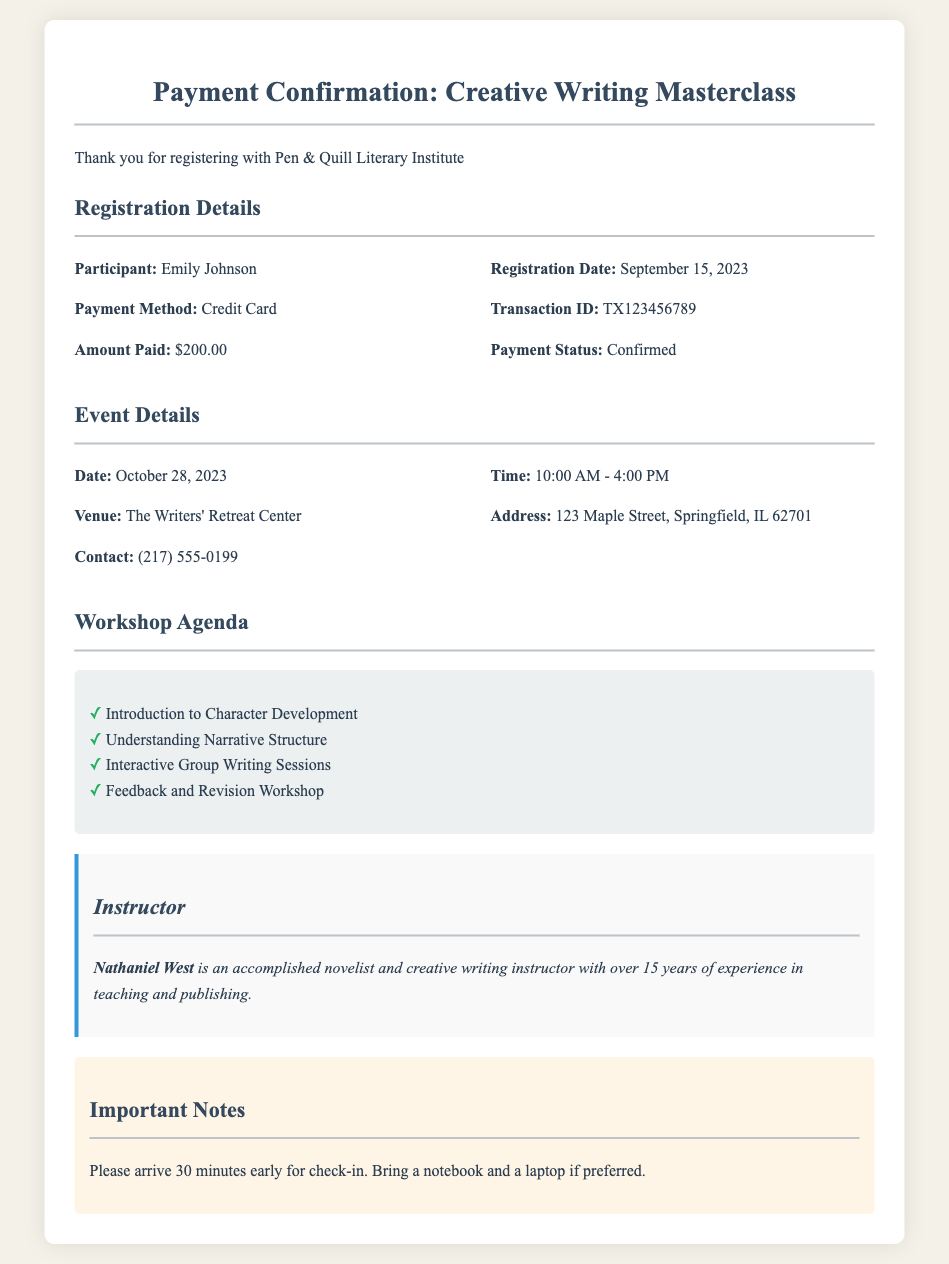What is the name of the participant? The name of the participant is mentioned in the registration details section of the document.
Answer: Emily Johnson What is the registration date? The registration date is specified in the confirmation details section.
Answer: September 15, 2023 What is the payment amount? The amount paid is clearly stated in the registration details of the document.
Answer: $200.00 What is the payment status? The payment status can be found in the confirmation details section of the document.
Answer: Confirmed What is the venue for the workshop? The venue is provided under the event details section in the document.
Answer: The Writers' Retreat Center What time does the workshop start? The start time for the workshop is listed in the event details.
Answer: 10:00 AM Who is the instructor? The instructor's name is highlighted in the instructor section of the document.
Answer: Nathaniel West How long is the workshop scheduled? The duration of the workshop can be inferred from the start and end times listed in the event details.
Answer: 6 hours What is an important note for participants? Important notes are mentioned in the notes section, indicating expectations for participants.
Answer: Please arrive 30 minutes early for check-in 